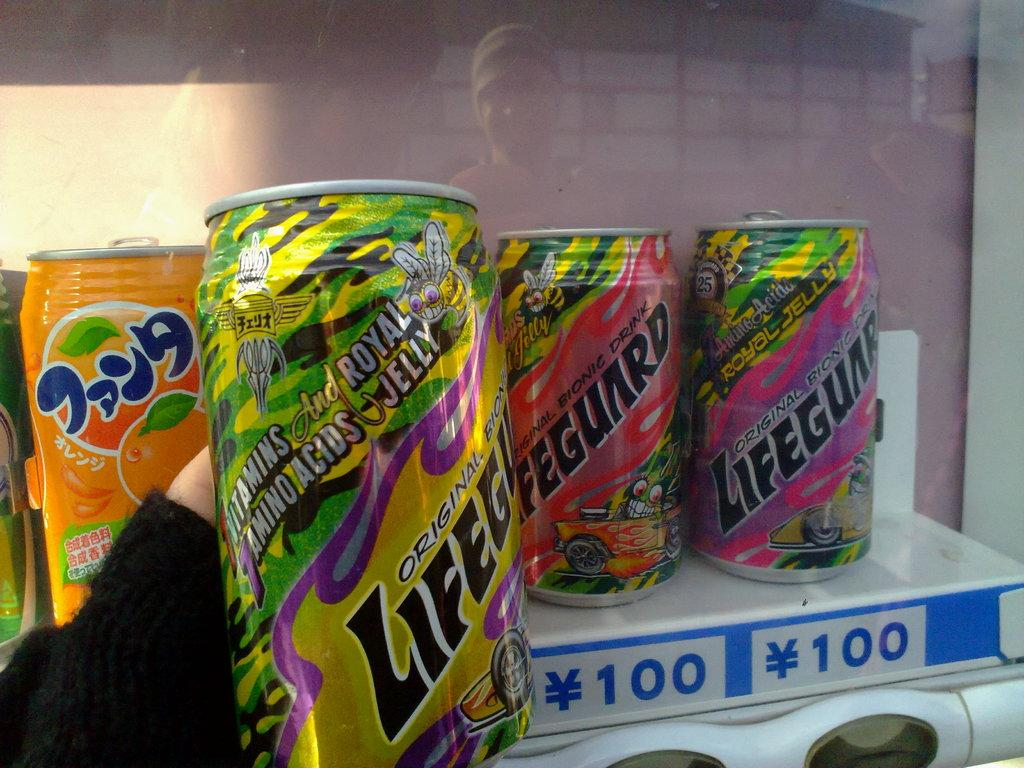<image>
Summarize the visual content of the image. A display of four cans of various flavors of Lifeguard drink showing the price underneath the cans. 